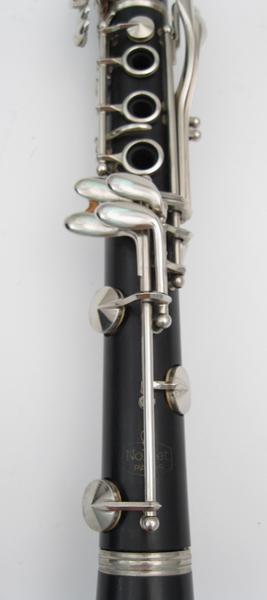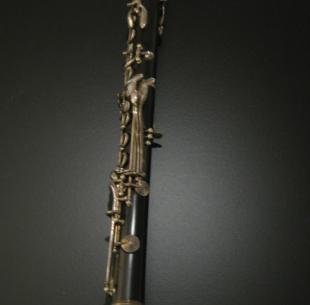The first image is the image on the left, the second image is the image on the right. Assess this claim about the two images: "One of the instruments is completely silver colored.". Correct or not? Answer yes or no. No. The first image is the image on the left, the second image is the image on the right. Analyze the images presented: Is the assertion "The instrument on the left is silver and is displayed at an angle, while the instrument on the right is a dark color and is displayed more vertically." valid? Answer yes or no. No. 